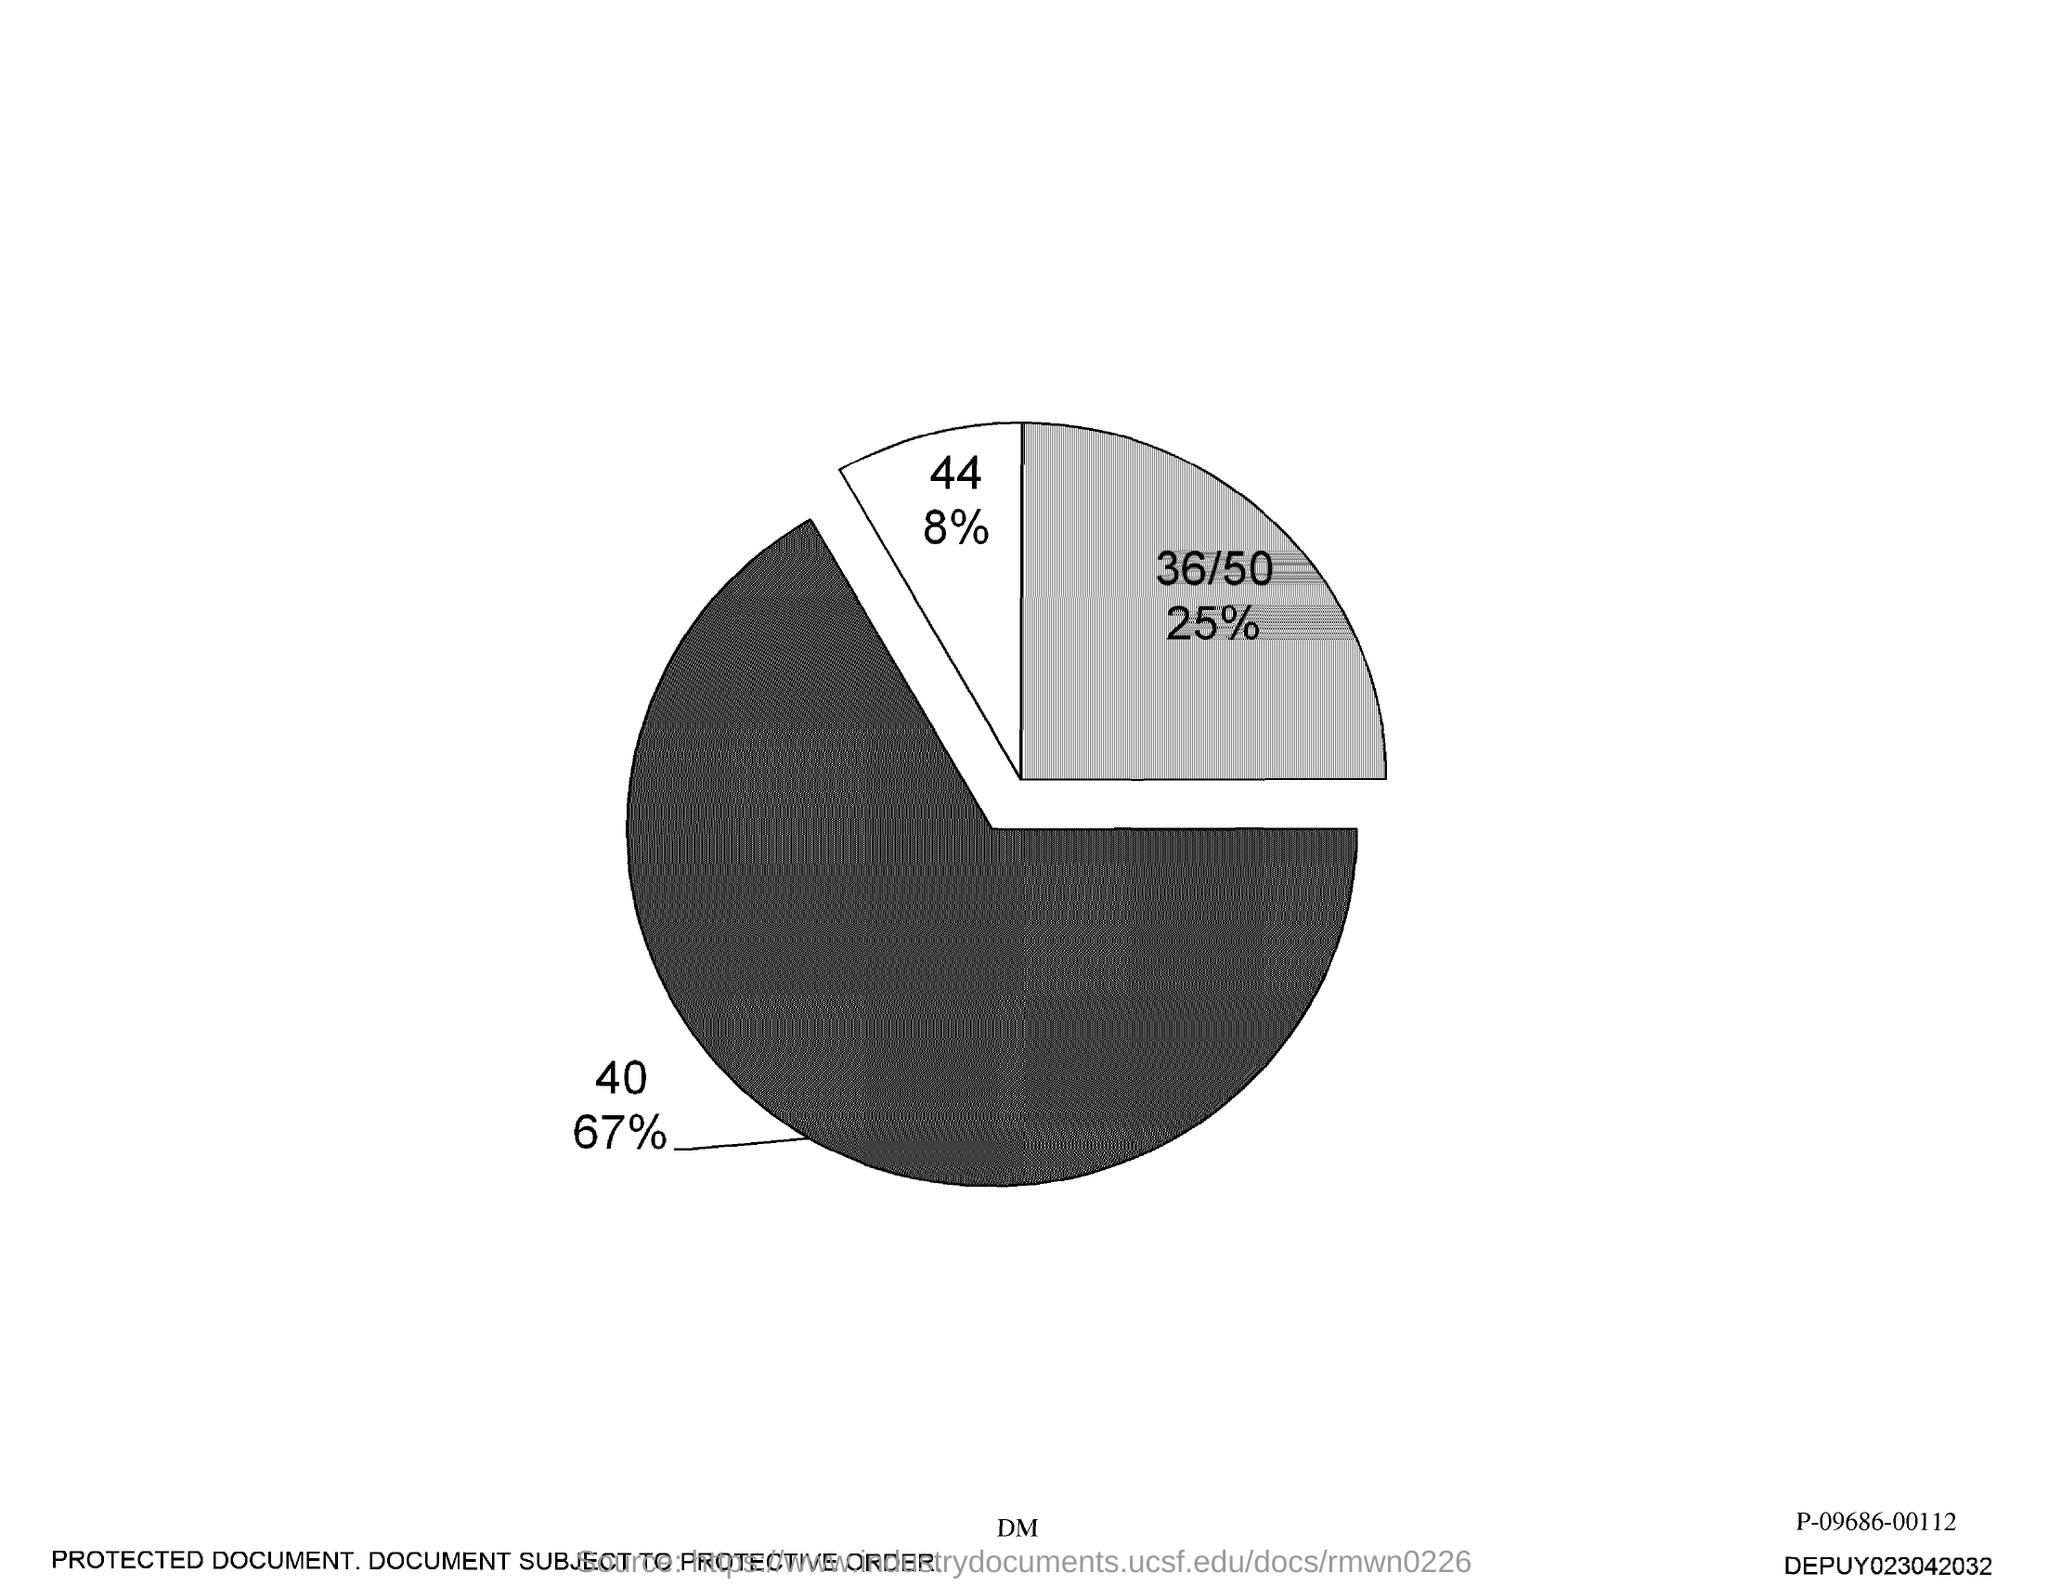Identify some key points in this picture. The second-highest percentage is 25%. The number associated with 8% is 44. What is the highest percentage? It is 67%. The lowest percentage is 8. 